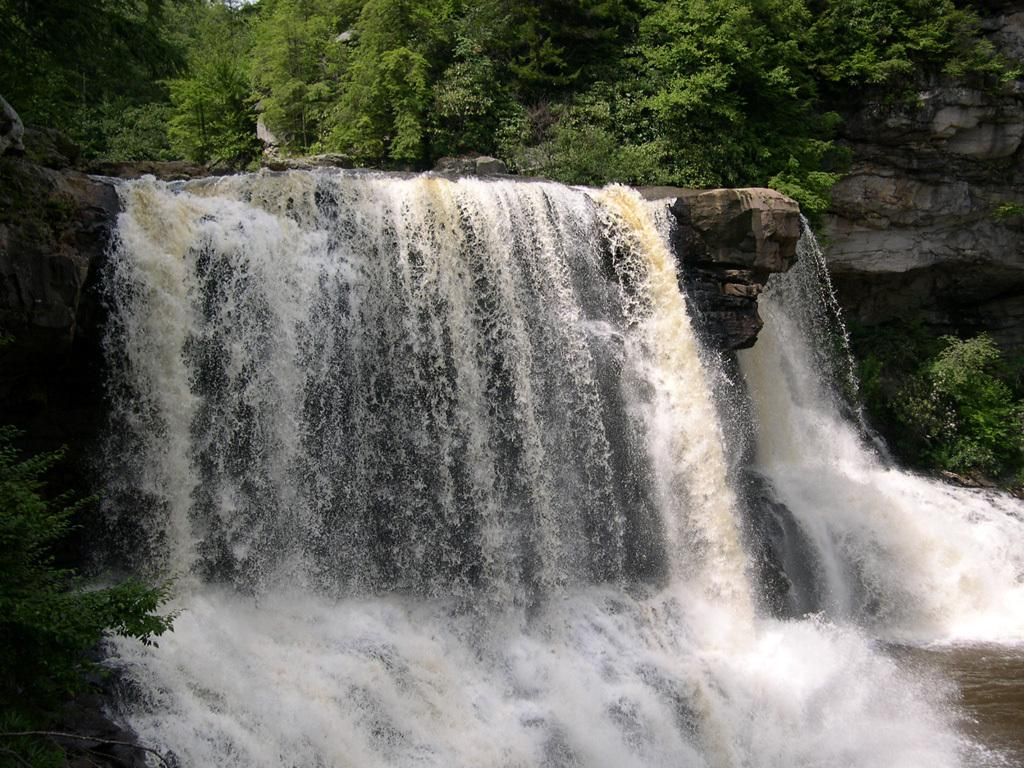What natural feature is the main subject of the image? There is a waterfall in the image. What type of geological formation can be seen in the image? There are rocks in the image. What type of vegetation is present in the image? There are many trees in the image. What type of pleasure can be seen enjoying the waterfall in the image? There is no person or creature present in the image to suggest that anyone is enjoying the waterfall. What type of self-reflection can be seen taking place near the waterfall in the image? There is no person or creature present in the image to suggest that anyone is engaging in self-reflection. 